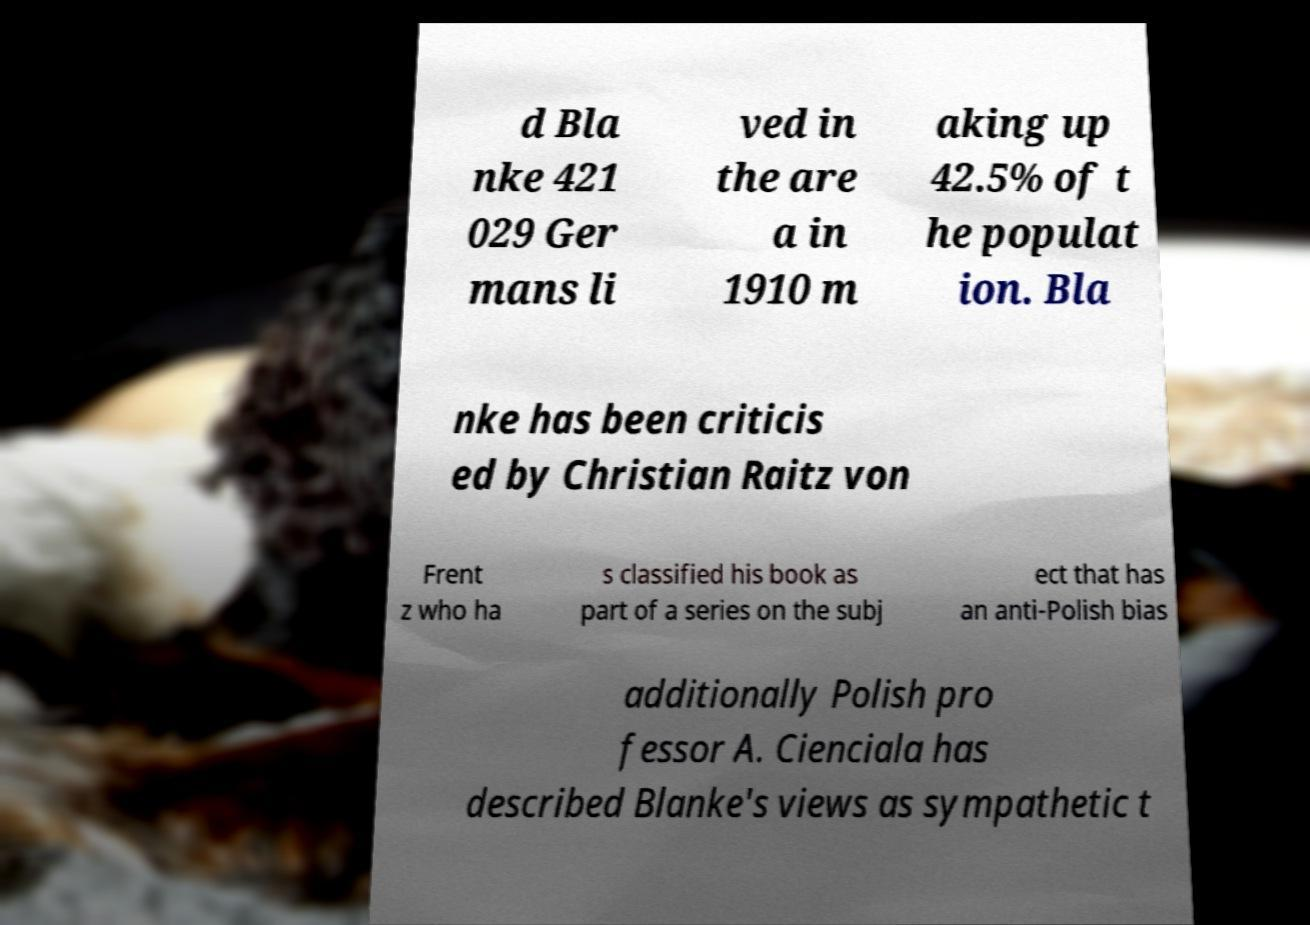Please identify and transcribe the text found in this image. d Bla nke 421 029 Ger mans li ved in the are a in 1910 m aking up 42.5% of t he populat ion. Bla nke has been criticis ed by Christian Raitz von Frent z who ha s classified his book as part of a series on the subj ect that has an anti-Polish bias additionally Polish pro fessor A. Cienciala has described Blanke's views as sympathetic t 